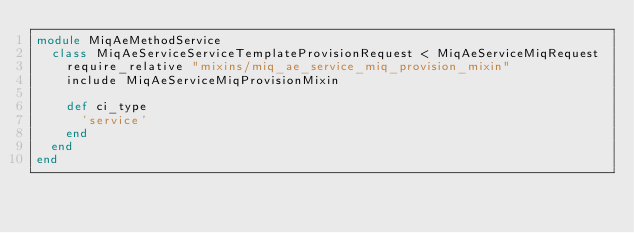Convert code to text. <code><loc_0><loc_0><loc_500><loc_500><_Ruby_>module MiqAeMethodService
  class MiqAeServiceServiceTemplateProvisionRequest < MiqAeServiceMiqRequest
    require_relative "mixins/miq_ae_service_miq_provision_mixin"
    include MiqAeServiceMiqProvisionMixin

    def ci_type
      'service'
    end
  end
end
</code> 